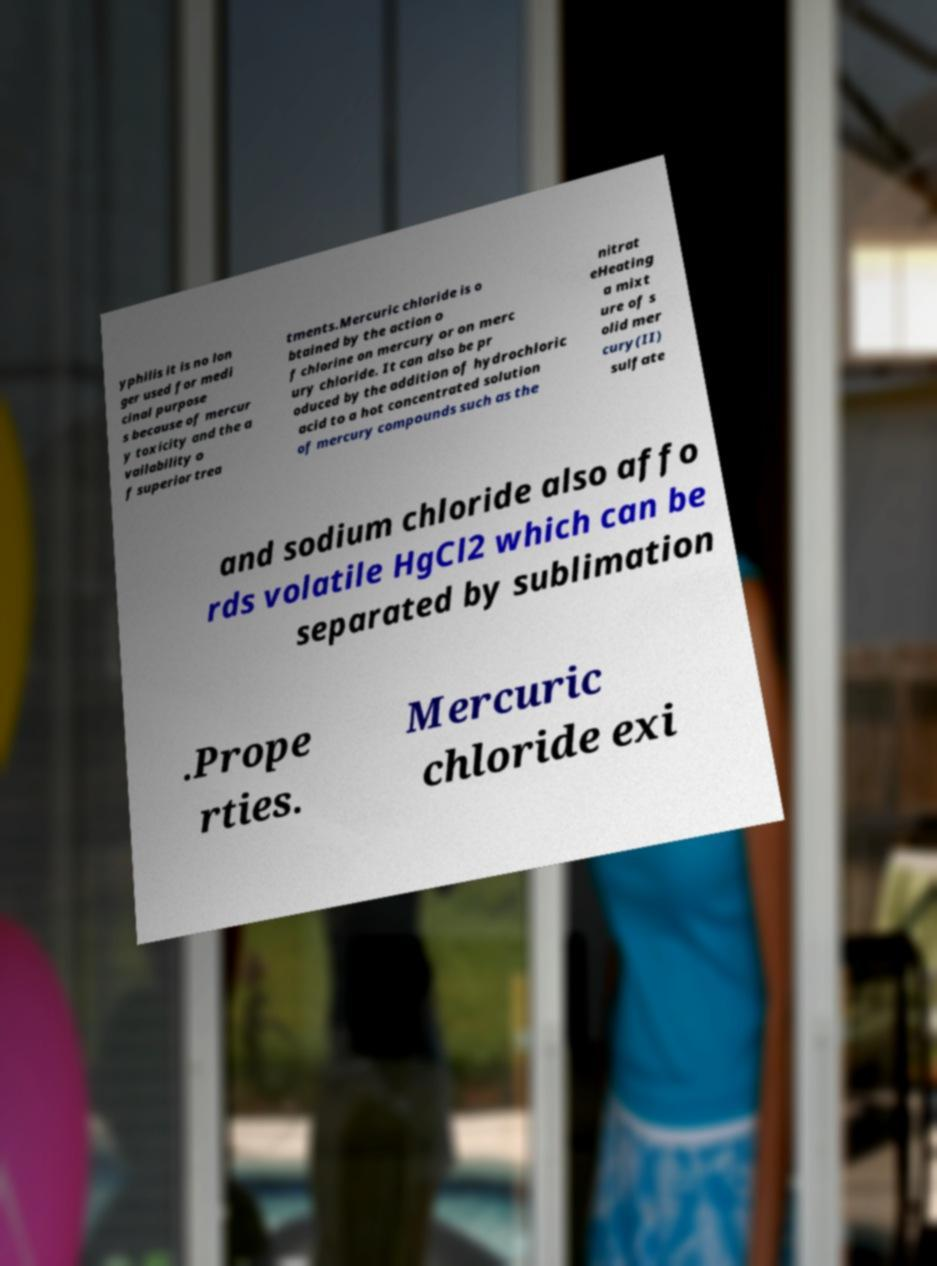Can you read and provide the text displayed in the image?This photo seems to have some interesting text. Can you extract and type it out for me? yphilis it is no lon ger used for medi cinal purpose s because of mercur y toxicity and the a vailability o f superior trea tments.Mercuric chloride is o btained by the action o f chlorine on mercury or on merc ury chloride. It can also be pr oduced by the addition of hydrochloric acid to a hot concentrated solution of mercury compounds such as the nitrat eHeating a mixt ure of s olid mer cury(II) sulfate and sodium chloride also affo rds volatile HgCl2 which can be separated by sublimation .Prope rties. Mercuric chloride exi 